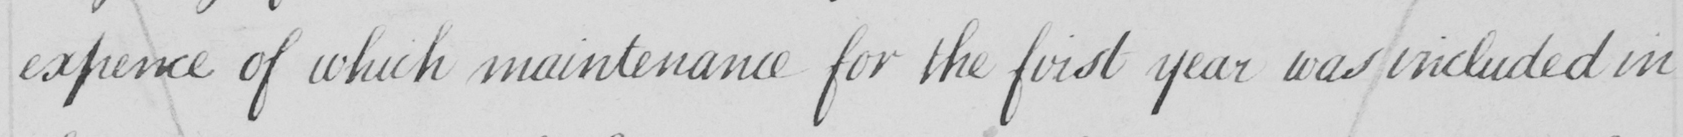Please transcribe the handwritten text in this image. expence of which maintenance for the first year was included in 